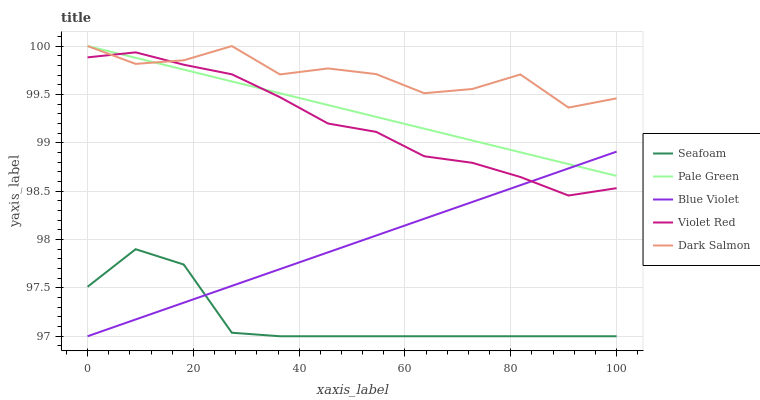Does Pale Green have the minimum area under the curve?
Answer yes or no. No. Does Pale Green have the maximum area under the curve?
Answer yes or no. No. Is Seafoam the smoothest?
Answer yes or no. No. Is Seafoam the roughest?
Answer yes or no. No. Does Pale Green have the lowest value?
Answer yes or no. No. Does Seafoam have the highest value?
Answer yes or no. No. Is Seafoam less than Pale Green?
Answer yes or no. Yes. Is Pale Green greater than Seafoam?
Answer yes or no. Yes. Does Seafoam intersect Pale Green?
Answer yes or no. No. 